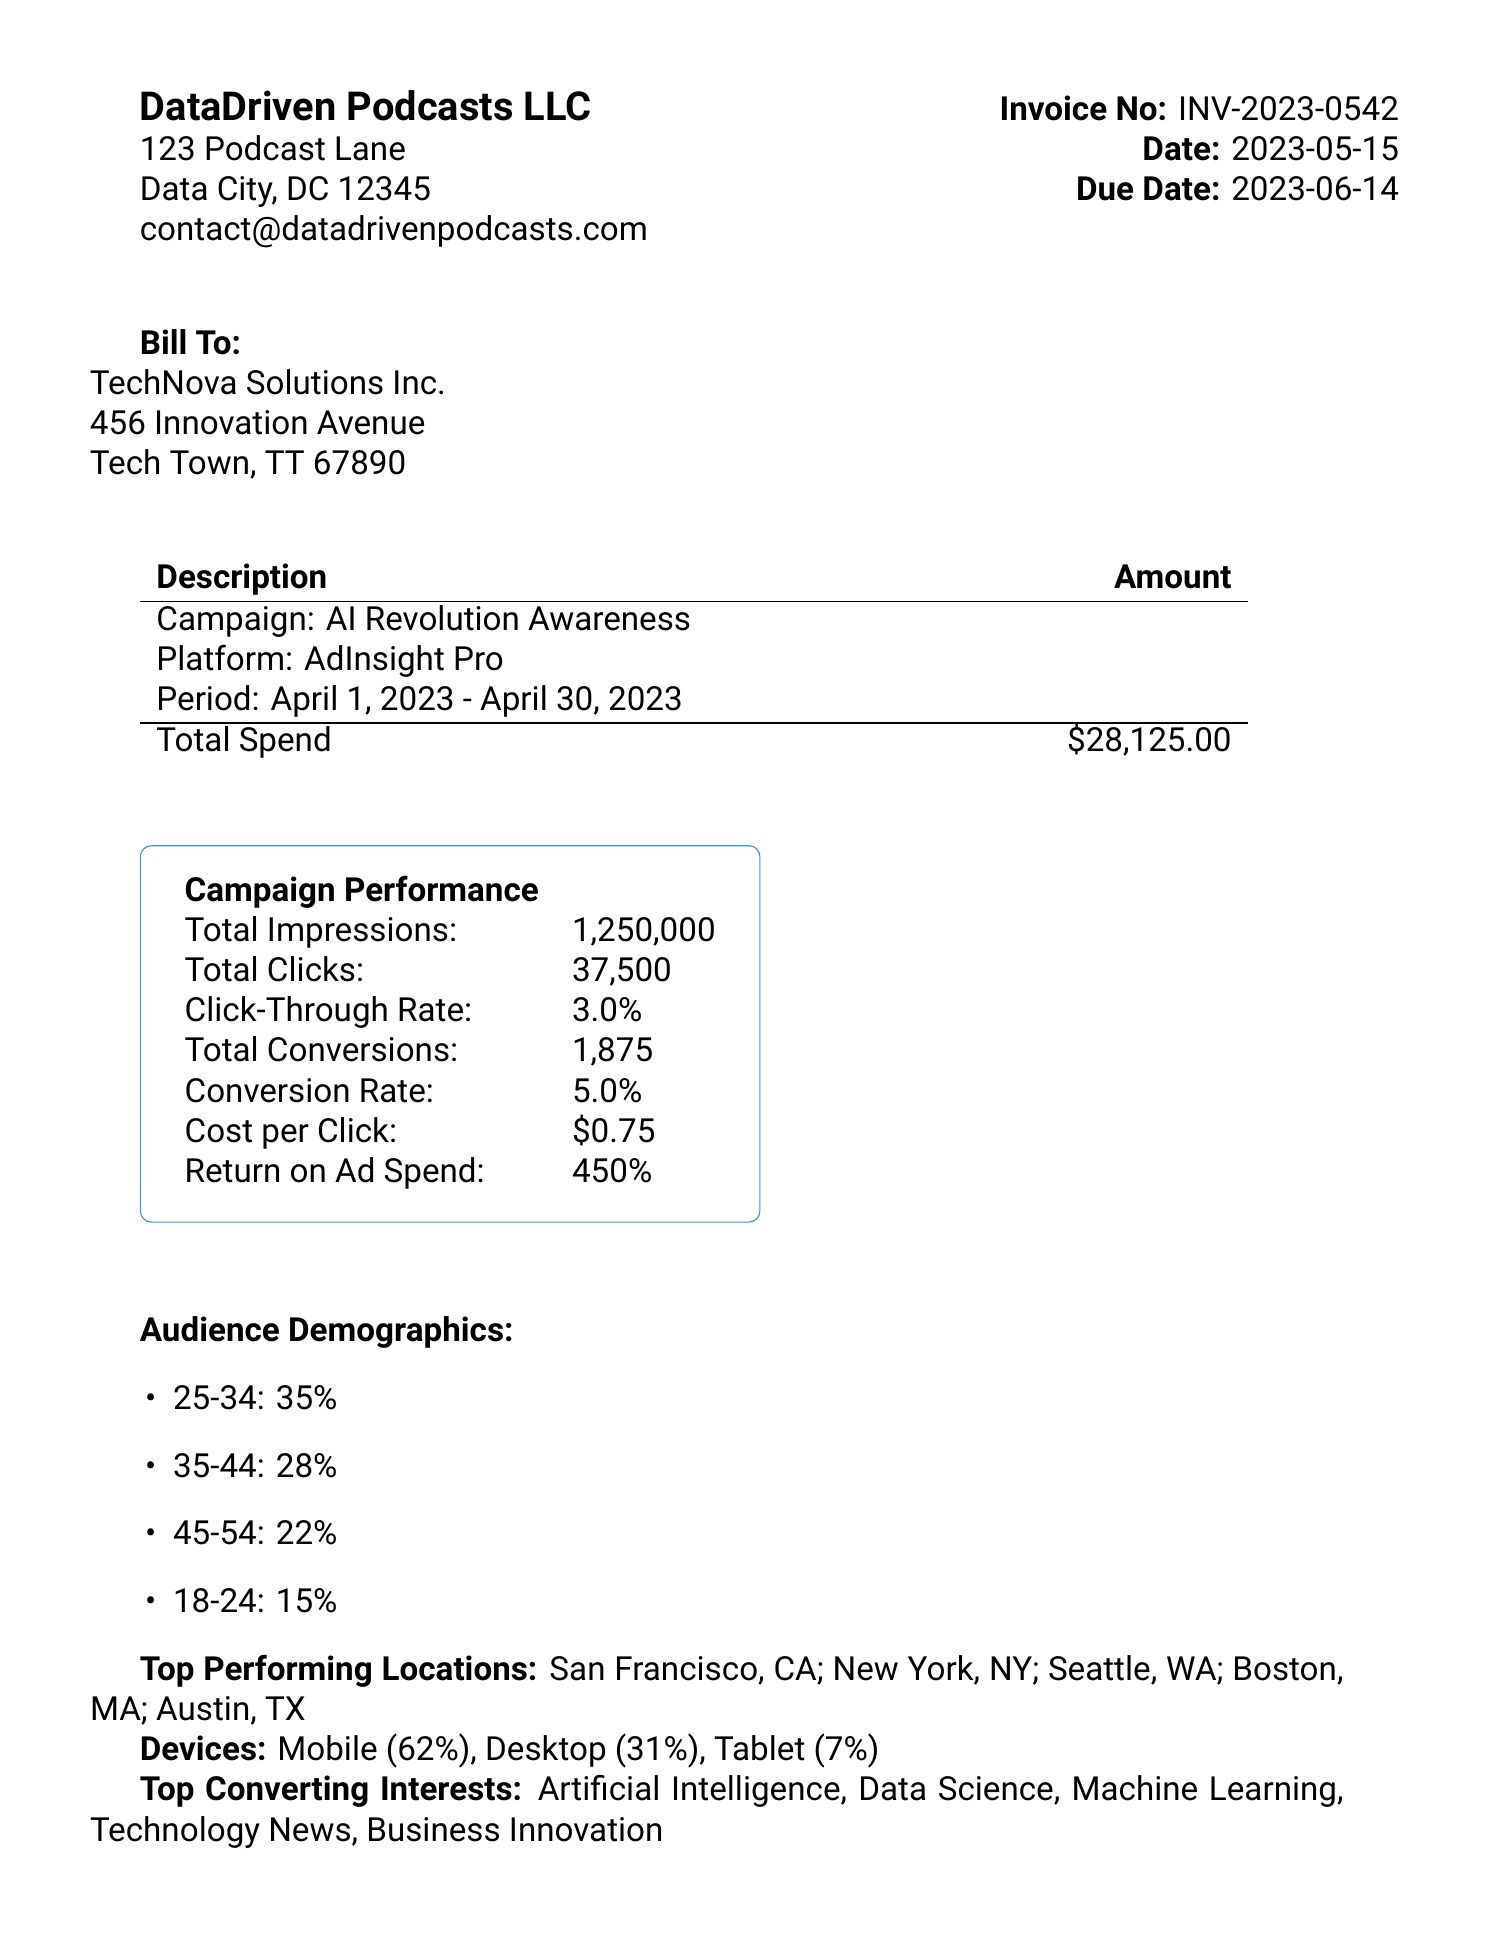What is the invoice number? The invoice number is provided in the document under the Invoice No section.
Answer: INV-2023-0542 What is the total spend for the campaign? The total spend is detailed in the invoice in the Total Spend section.
Answer: $28,125.00 What is the click-through rate? The click-through rate is specified in the Campaign Performance section of the document.
Answer: 3.0% What age group has the highest percentage in the audience demographics? The document lists audience demographics, and the age group with the highest percentage is noted.
Answer: 25-34 How many top-performing locations are listed? The document mentions several top-performing locations that can be counted.
Answer: 5 What payment terms are stated in the invoice? The payment terms are specifically mentioned towards the end of the document.
Answer: Net 30 What percentage of impressions led to conversions? The conversion rate can be calculated from the provided total conversions and total impressions.
Answer: 5.0% What is the total number of clicks? The total number of clicks is specified in the Campaign Performance section.
Answer: 37,500 What are the payment methods listed? The payment methods are mentioned towards the end of the invoice.
Answer: Credit Card, PayPal, Bank Transfer 